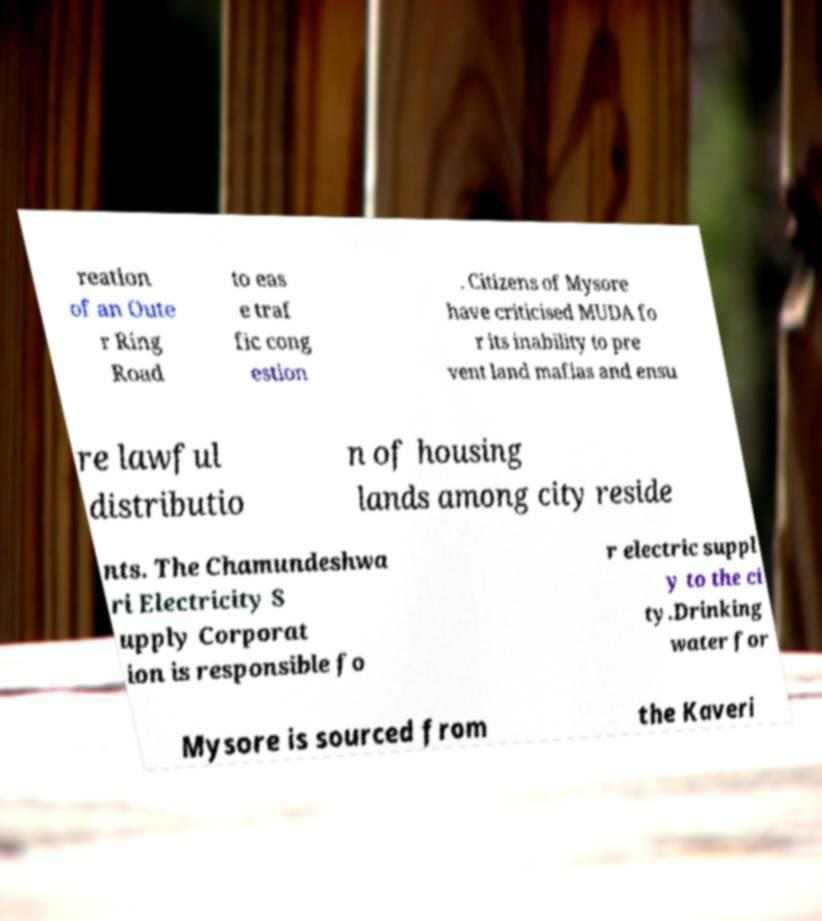Please read and relay the text visible in this image. What does it say? reation of an Oute r Ring Road to eas e traf fic cong estion . Citizens of Mysore have criticised MUDA fo r its inability to pre vent land mafias and ensu re lawful distributio n of housing lands among city reside nts. The Chamundeshwa ri Electricity S upply Corporat ion is responsible fo r electric suppl y to the ci ty.Drinking water for Mysore is sourced from the Kaveri 